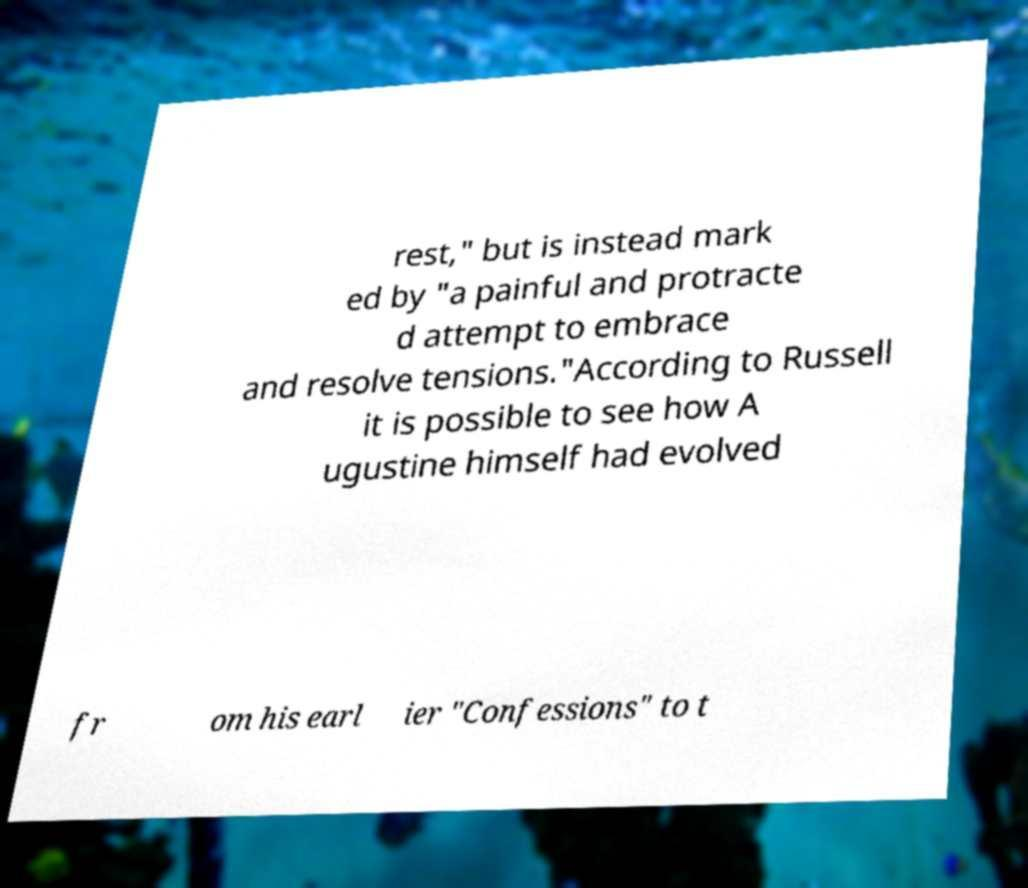There's text embedded in this image that I need extracted. Can you transcribe it verbatim? rest," but is instead mark ed by "a painful and protracte d attempt to embrace and resolve tensions."According to Russell it is possible to see how A ugustine himself had evolved fr om his earl ier "Confessions" to t 